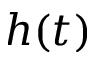Convert formula to latex. <formula><loc_0><loc_0><loc_500><loc_500>h ( t )</formula> 